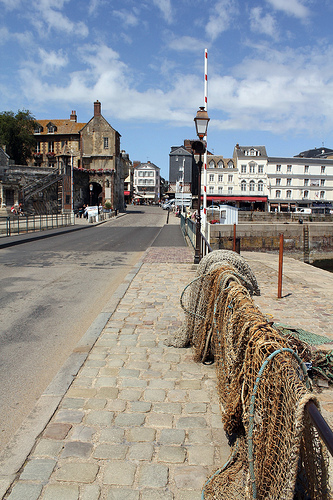<image>
Is there a building behind the road? Yes. From this viewpoint, the building is positioned behind the road, with the road partially or fully occluding the building. 